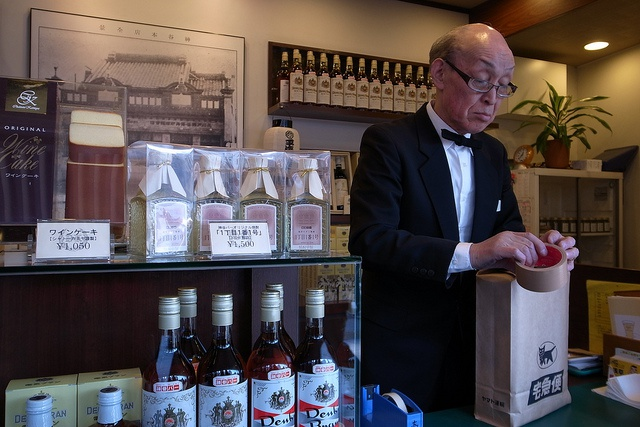Describe the objects in this image and their specific colors. I can see people in gray, black, and maroon tones, bottle in gray, lavender, black, and darkgray tones, potted plant in gray, black, olive, and maroon tones, bottle in gray, black, and lightblue tones, and bottle in gray, black, and lightblue tones in this image. 